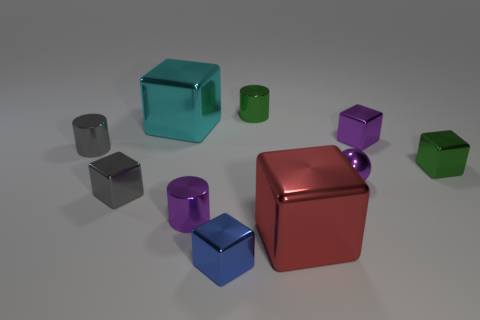There is a metal thing that is both right of the tiny blue shiny block and in front of the purple metallic sphere; what shape is it?
Your response must be concise. Cube. How many other objects are there of the same shape as the red shiny object?
Your response must be concise. 5. There is a metal ball that is the same size as the blue shiny thing; what color is it?
Your response must be concise. Purple. How many things are purple things or cyan metallic cubes?
Offer a very short reply. 4. There is a purple cylinder; are there any big blocks right of it?
Your answer should be compact. Yes. Is there a tiny purple cylinder that has the same material as the small purple sphere?
Your answer should be very brief. Yes. The metallic cylinder that is the same color as the small sphere is what size?
Offer a very short reply. Small. What number of cubes are either red metallic things or small blue objects?
Give a very brief answer. 2. Are there more small objects in front of the small gray cylinder than small metallic things that are right of the blue thing?
Keep it short and to the point. Yes. What number of cubes have the same color as the small ball?
Provide a succinct answer. 1. 